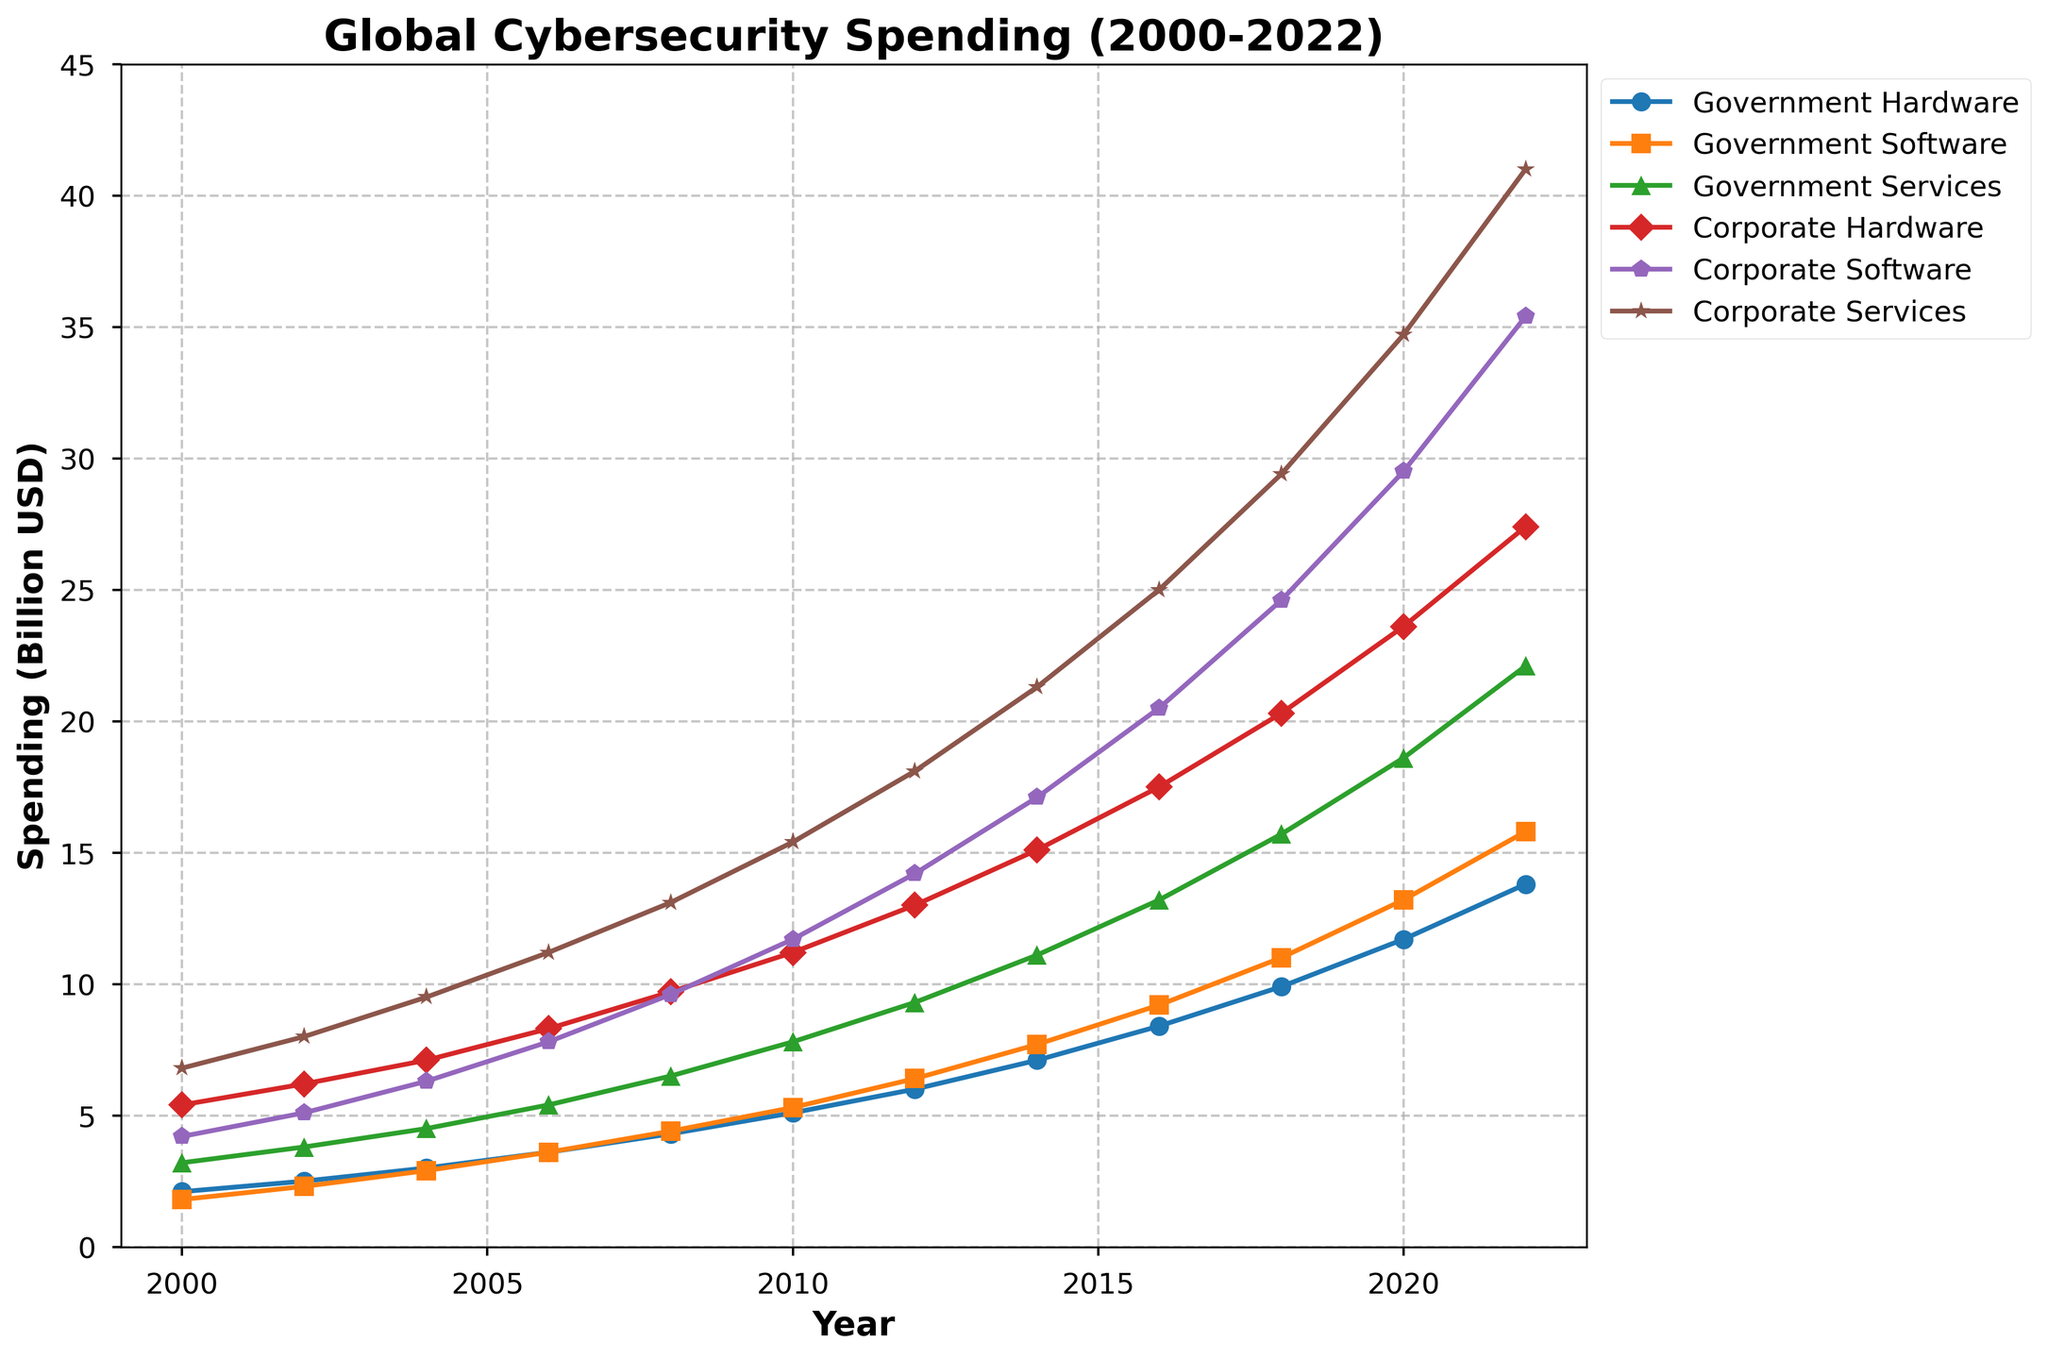What's the total cybersecurity spending by governments in 2010, combining hardware, software, and services? To find the total, sum the government spending on hardware, software, and services for 2010: 5.1 + 5.3 + 7.8.
Answer: 18.2 billion USD Which had a greater increase in software spending from 2000 to 2022, governments or corporations? Calculate the difference in software spending for governments and corporations between 2000 and 2022. For governments: 15.8 - 1.8 = 14.0. For corporations: 35.4 - 4.2 = 31.2. Compare the two differences.
Answer: Corporations In what year do corporations first exceed 20 billion USD in hardware spending? Check the corporate hardware spending values to identify the first year when spending exceeded 20 billion USD. The first exceeding value is 2020 at 23.6 billion USD.
Answer: 2020 How does the government hardware spending trend visually compare to corporate hardware spending? Visually, both government and corporate hardware spending trends show a consistent increase, but corporate spending grows at a faster rate and in larger increments than government spending.
Answer: Corporations grow faster Which category has the highest spending in 2022, and how much is it? Compare the 2022 spending values of all categories. Corporate services spending is highest at 41.0 billion USD.
Answer: Corporate Services, 41.0 billion USD What is the difference in total spending between governments and corporations in 2018? Calculate the total spending for both governments and corporations in 2018. Governments: 9.9 + 11.0 + 15.7 = 36.6. Corporations: 20.3 + 24.6 + 29.4 = 74.3. Find the difference: 74.3 - 36.6.
Answer: 37.7 billion USD What year saw the largest year-over-year increase in government software spending? Identify the year-wise increase in government software spending and find the largest increase. Largest increase from 2020 to 2022: 15.8 - 13.2 = 2.6 (Note: consider the 2-year interval).
Answer: 2022 In 2008, how much more did corporations spend on services compared to governments? Subtract the government services spending from the corporate services spending in 2008: 13.1 - 6.5.
Answer: 6.6 billion USD 